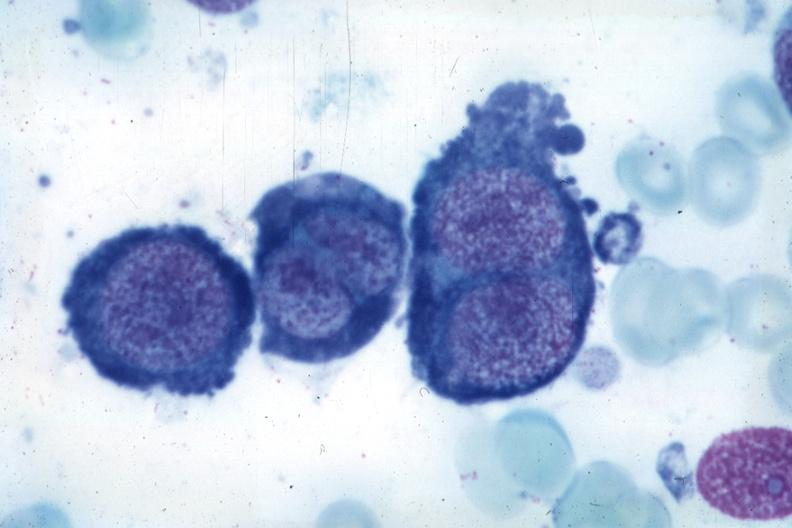does this image show wrights typical cells?
Answer the question using a single word or phrase. Yes 